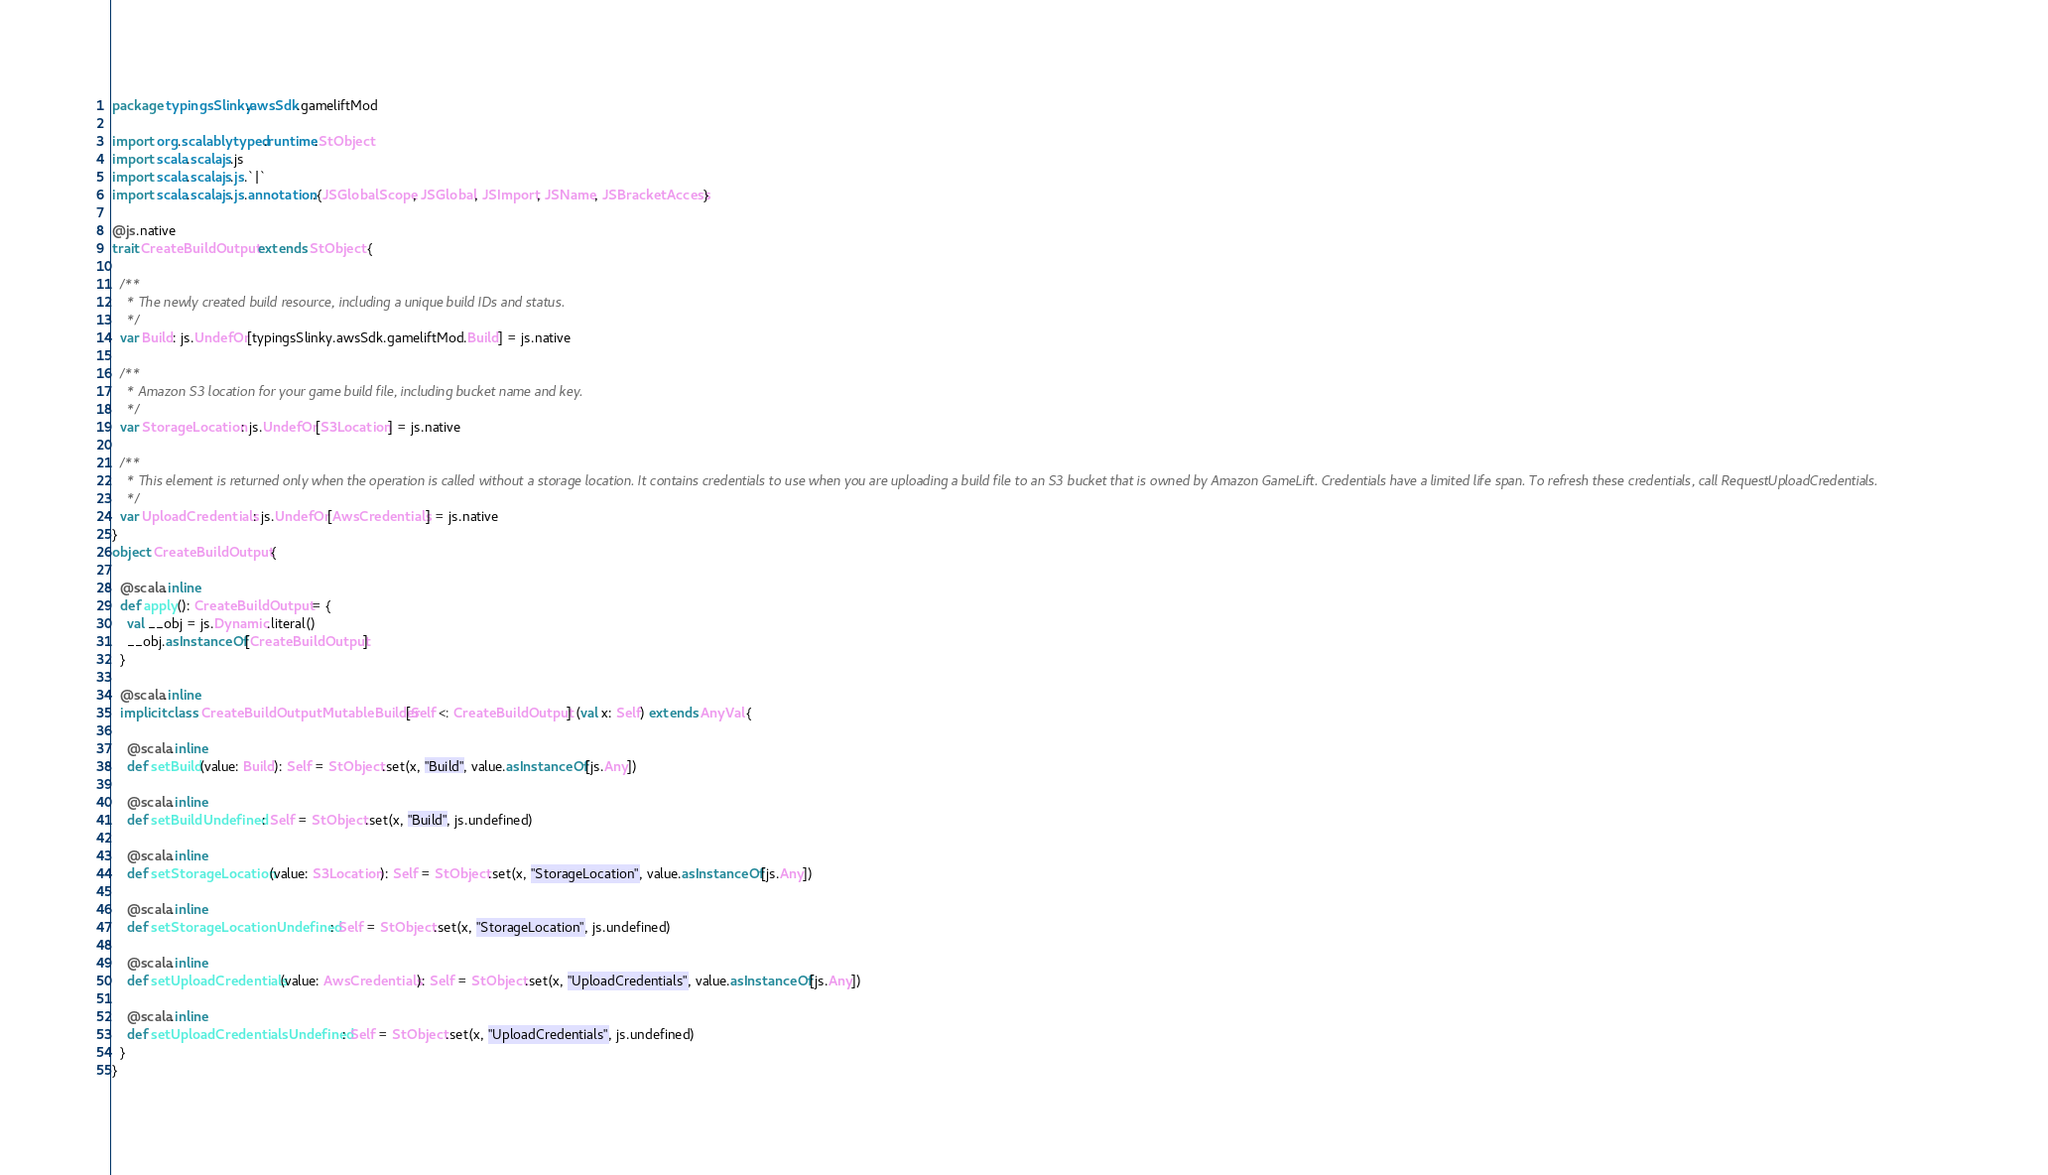Convert code to text. <code><loc_0><loc_0><loc_500><loc_500><_Scala_>package typingsSlinky.awsSdk.gameliftMod

import org.scalablytyped.runtime.StObject
import scala.scalajs.js
import scala.scalajs.js.`|`
import scala.scalajs.js.annotation.{JSGlobalScope, JSGlobal, JSImport, JSName, JSBracketAccess}

@js.native
trait CreateBuildOutput extends StObject {
  
  /**
    * The newly created build resource, including a unique build IDs and status. 
    */
  var Build: js.UndefOr[typingsSlinky.awsSdk.gameliftMod.Build] = js.native
  
  /**
    * Amazon S3 location for your game build file, including bucket name and key.
    */
  var StorageLocation: js.UndefOr[S3Location] = js.native
  
  /**
    * This element is returned only when the operation is called without a storage location. It contains credentials to use when you are uploading a build file to an S3 bucket that is owned by Amazon GameLift. Credentials have a limited life span. To refresh these credentials, call RequestUploadCredentials. 
    */
  var UploadCredentials: js.UndefOr[AwsCredentials] = js.native
}
object CreateBuildOutput {
  
  @scala.inline
  def apply(): CreateBuildOutput = {
    val __obj = js.Dynamic.literal()
    __obj.asInstanceOf[CreateBuildOutput]
  }
  
  @scala.inline
  implicit class CreateBuildOutputMutableBuilder[Self <: CreateBuildOutput] (val x: Self) extends AnyVal {
    
    @scala.inline
    def setBuild(value: Build): Self = StObject.set(x, "Build", value.asInstanceOf[js.Any])
    
    @scala.inline
    def setBuildUndefined: Self = StObject.set(x, "Build", js.undefined)
    
    @scala.inline
    def setStorageLocation(value: S3Location): Self = StObject.set(x, "StorageLocation", value.asInstanceOf[js.Any])
    
    @scala.inline
    def setStorageLocationUndefined: Self = StObject.set(x, "StorageLocation", js.undefined)
    
    @scala.inline
    def setUploadCredentials(value: AwsCredentials): Self = StObject.set(x, "UploadCredentials", value.asInstanceOf[js.Any])
    
    @scala.inline
    def setUploadCredentialsUndefined: Self = StObject.set(x, "UploadCredentials", js.undefined)
  }
}
</code> 